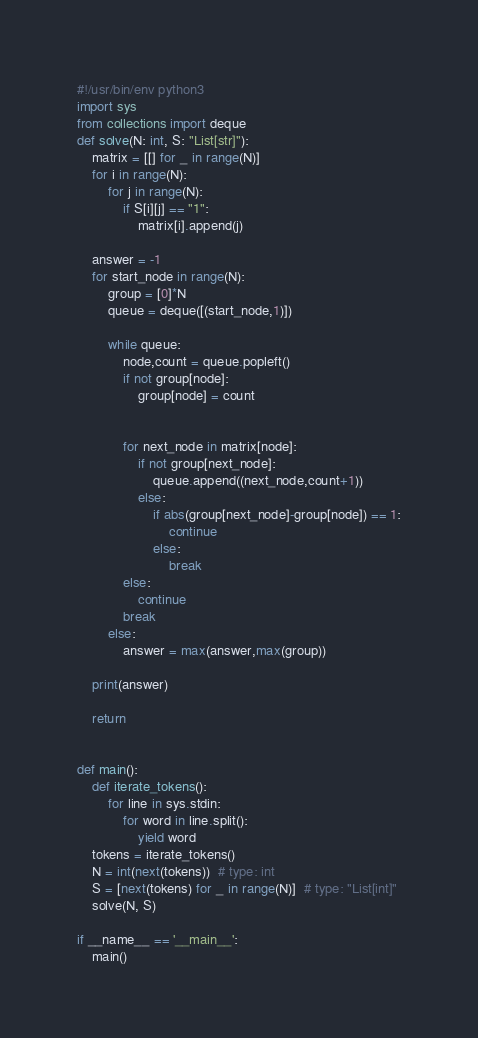Convert code to text. <code><loc_0><loc_0><loc_500><loc_500><_Python_>#!/usr/bin/env python3
import sys
from collections import deque
def solve(N: int, S: "List[str]"):
    matrix = [[] for _ in range(N)]
    for i in range(N):
        for j in range(N):
            if S[i][j] == "1":
                matrix[i].append(j)

    answer = -1
    for start_node in range(N):
        group = [0]*N
        queue = deque([(start_node,1)])

        while queue:
            node,count = queue.popleft()
            if not group[node]:
                group[node] = count
    

            for next_node in matrix[node]:
                if not group[next_node]:
                    queue.append((next_node,count+1))
                else:
                    if abs(group[next_node]-group[node]) == 1:
                        continue
                    else:
                        break
            else:
                continue
            break
        else:
            answer = max(answer,max(group))

    print(answer)

    return


def main():
    def iterate_tokens():
        for line in sys.stdin:
            for word in line.split():
                yield word
    tokens = iterate_tokens()
    N = int(next(tokens))  # type: int
    S = [next(tokens) for _ in range(N)]  # type: "List[int]"
    solve(N, S)

if __name__ == '__main__':
    main()
</code> 